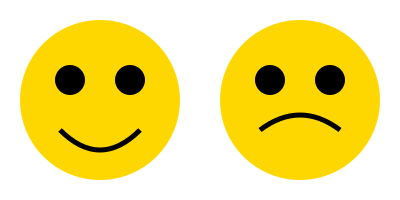As a life coach recognizing emotional intelligence cues, which facial expression illustration depicts a higher level of genuine happiness and positive engagement? To analyze the emotional intelligence cues in these facial expression illustrations, we need to consider the following steps:

1. Eye shape: In both illustrations, the eyes are represented by filled circles, indicating open and alert eyes.

2. Mouth shape: This is the key differentiator between the two expressions.
   a. Left face: The mouth is curved upwards in a U-shape, forming a broad smile.
   b. Right face: The mouth is curved slightly upwards, forming a subtle smile.

3. Duchenne smile: A genuine smile, also known as a Duchenne smile, involves not just the mouth but also the eyes. The left face shows more pronounced cheek elevation, which would typically accompany a genuine smile.

4. Overall expression:
   a. Left face: The combination of wide-open eyes and a broad smile suggests enthusiasm, joy, and high positive engagement.
   b. Right face: The open eyes with a subtle smile indicate a pleasant but more reserved or neutral emotional state.

5. Leadership context: As a life coach recognizing leadership skills, it's important to note that leaders who display genuine positive emotions tend to be more effective in engaging and motivating their teams.

Based on these observations, the left facial expression illustration depicts a higher level of genuine happiness and positive engagement, which would be more impactful in a leadership context.
Answer: Left facial expression 